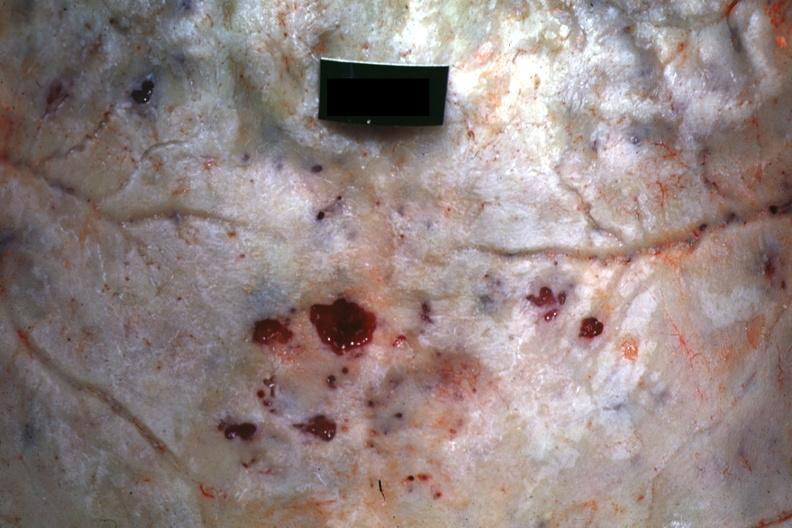s carcinoma metastatic lung present?
Answer the question using a single word or phrase. No 